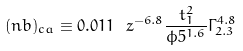<formula> <loc_0><loc_0><loc_500><loc_500>( n b ) _ { c a } \equiv 0 . 0 1 1 \ z ^ { - 6 . 8 } \frac { t _ { 1 } ^ { 2 } } { \phi 5 ^ { 1 . 6 } } \Gamma _ { 2 . 3 } ^ { 4 . 8 }</formula> 